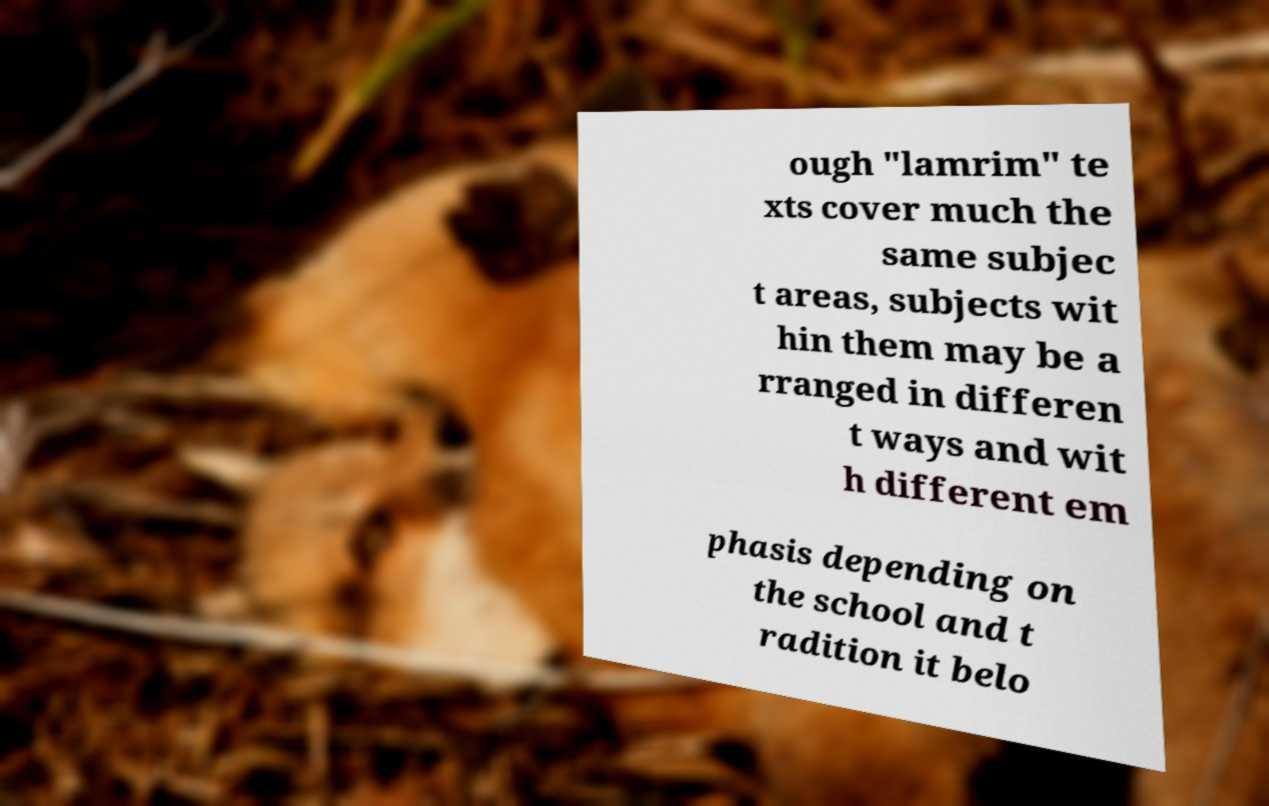Can you read and provide the text displayed in the image?This photo seems to have some interesting text. Can you extract and type it out for me? ough "lamrim" te xts cover much the same subjec t areas, subjects wit hin them may be a rranged in differen t ways and wit h different em phasis depending on the school and t radition it belo 